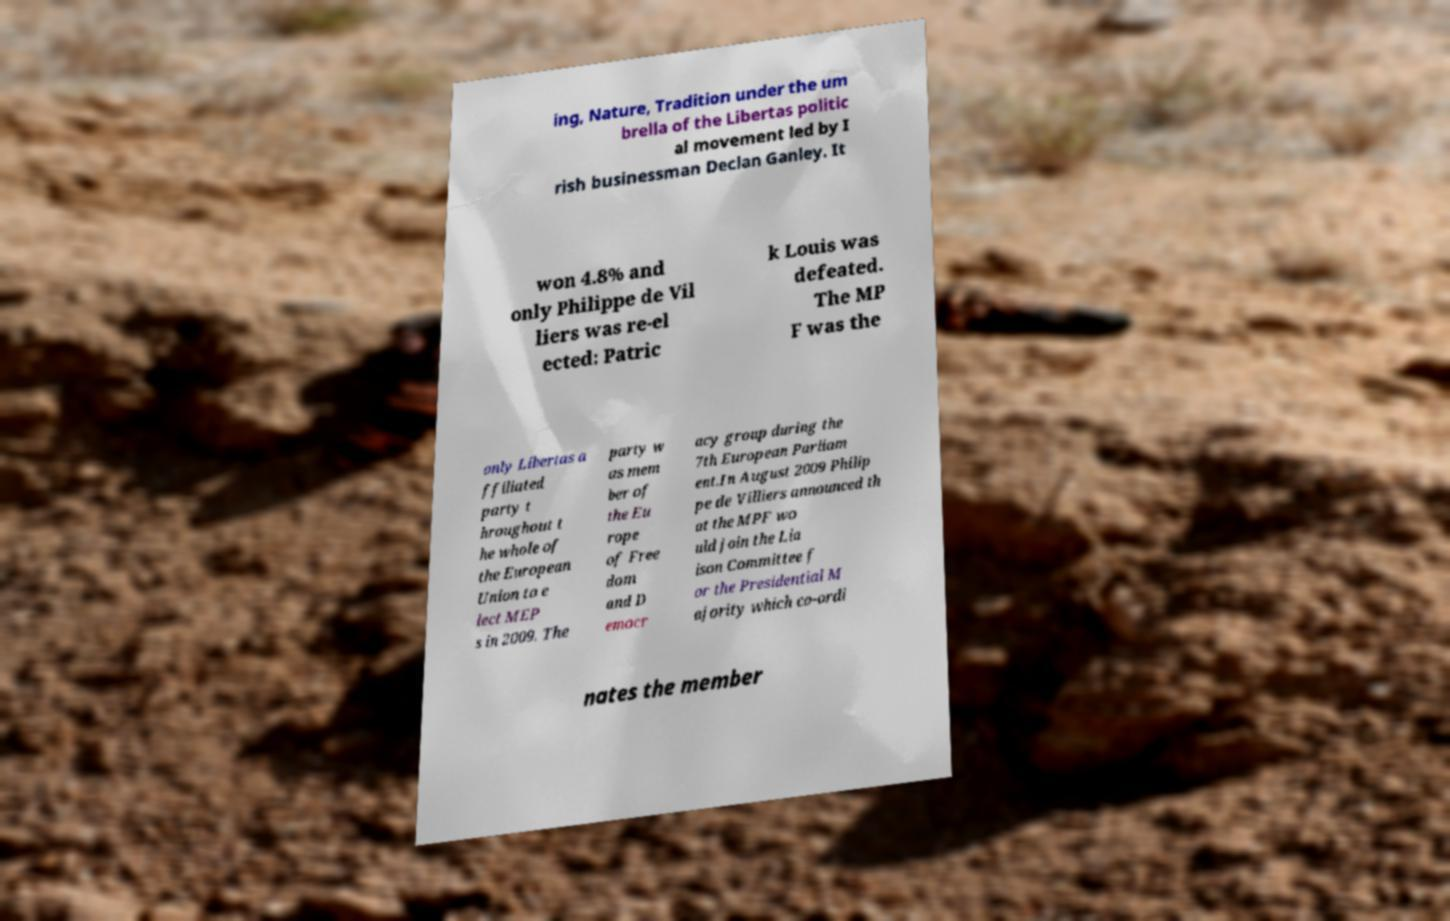Could you extract and type out the text from this image? ing, Nature, Tradition under the um brella of the Libertas politic al movement led by I rish businessman Declan Ganley. It won 4.8% and only Philippe de Vil liers was re-el ected: Patric k Louis was defeated. The MP F was the only Libertas a ffiliated party t hroughout t he whole of the European Union to e lect MEP s in 2009. The party w as mem ber of the Eu rope of Free dom and D emocr acy group during the 7th European Parliam ent.In August 2009 Philip pe de Villiers announced th at the MPF wo uld join the Lia ison Committee f or the Presidential M ajority which co-ordi nates the member 